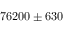<formula> <loc_0><loc_0><loc_500><loc_500>7 6 2 0 0 \pm 6 3 0</formula> 